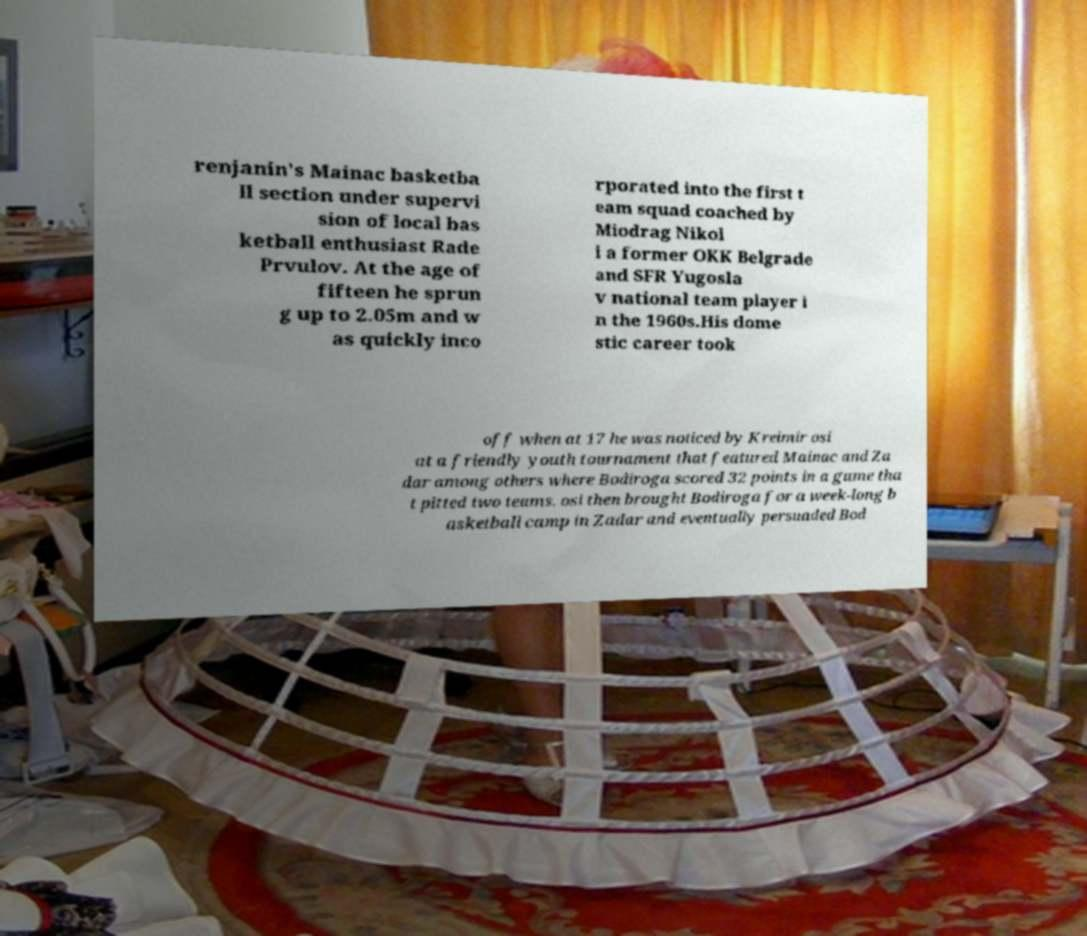Can you accurately transcribe the text from the provided image for me? renjanin's Mainac basketba ll section under supervi sion of local bas ketball enthusiast Rade Prvulov. At the age of fifteen he sprun g up to 2.05m and w as quickly inco rporated into the first t eam squad coached by Miodrag Nikol i a former OKK Belgrade and SFR Yugosla v national team player i n the 1960s.His dome stic career took off when at 17 he was noticed by Kreimir osi at a friendly youth tournament that featured Mainac and Za dar among others where Bodiroga scored 32 points in a game tha t pitted two teams. osi then brought Bodiroga for a week-long b asketball camp in Zadar and eventually persuaded Bod 